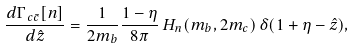Convert formula to latex. <formula><loc_0><loc_0><loc_500><loc_500>\frac { d \Gamma _ { \, c \bar { c } } [ n ] } { d \hat { z } } = \frac { 1 } { 2 m _ { b } } \frac { 1 - \eta } { 8 \pi } \, H _ { n } ( m _ { b } , 2 m _ { c } ) \, \delta ( 1 + \eta - \hat { z } ) ,</formula> 